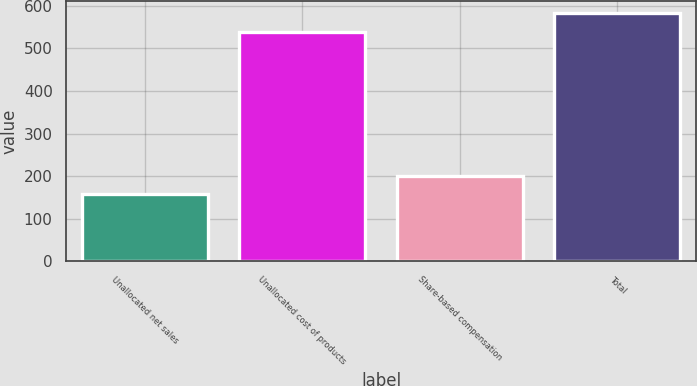<chart> <loc_0><loc_0><loc_500><loc_500><bar_chart><fcel>Unallocated net sales<fcel>Unallocated cost of products<fcel>Share-based compensation<fcel>Total<nl><fcel>157<fcel>538<fcel>201<fcel>582<nl></chart> 